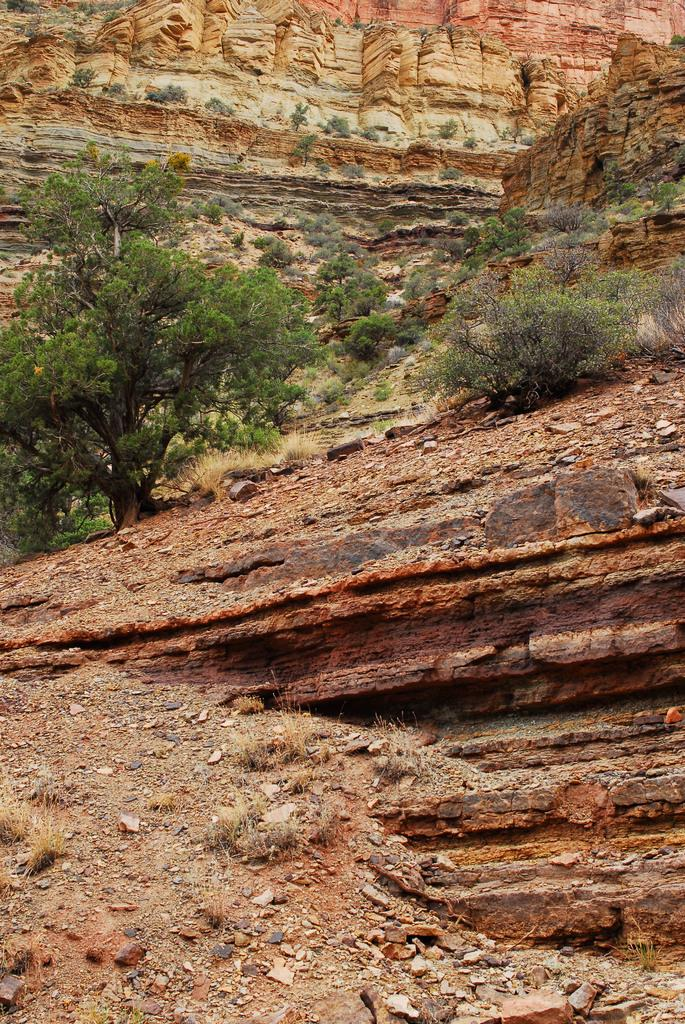What type of vegetation can be seen in the image? There are trees and plants in the image. What type of landscape feature is present in the image? There are hills in the image. Can you see any goldfish swimming in the image? There are no goldfish present in the image. What type of balls can be seen in the image? There are no balls present in the image. 